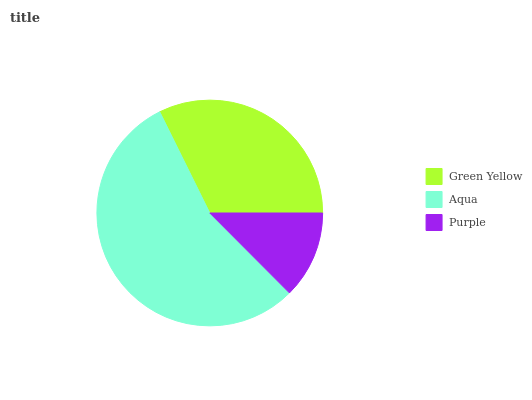Is Purple the minimum?
Answer yes or no. Yes. Is Aqua the maximum?
Answer yes or no. Yes. Is Aqua the minimum?
Answer yes or no. No. Is Purple the maximum?
Answer yes or no. No. Is Aqua greater than Purple?
Answer yes or no. Yes. Is Purple less than Aqua?
Answer yes or no. Yes. Is Purple greater than Aqua?
Answer yes or no. No. Is Aqua less than Purple?
Answer yes or no. No. Is Green Yellow the high median?
Answer yes or no. Yes. Is Green Yellow the low median?
Answer yes or no. Yes. Is Aqua the high median?
Answer yes or no. No. Is Purple the low median?
Answer yes or no. No. 